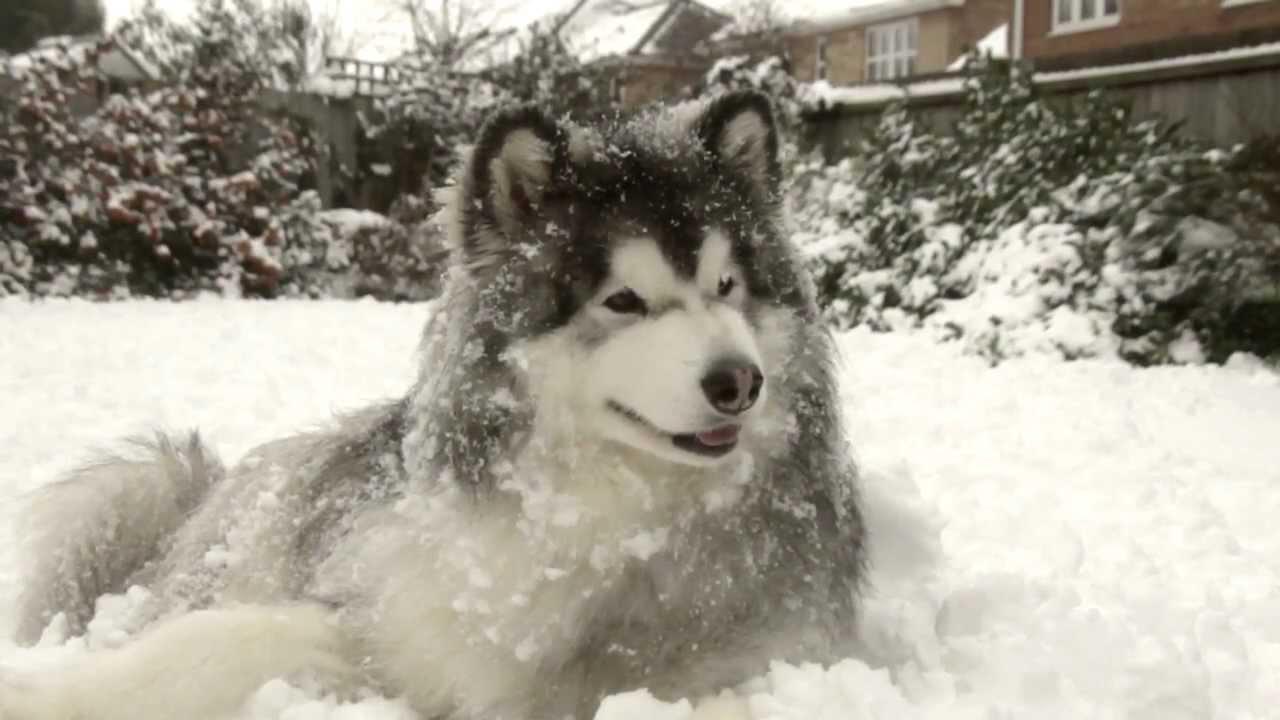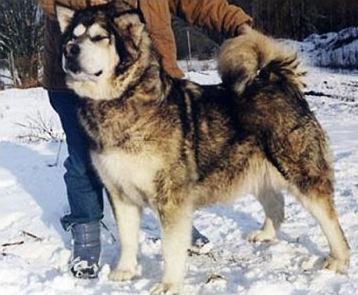The first image is the image on the left, the second image is the image on the right. Analyze the images presented: Is the assertion "The left and right image contains the same number of dogs with at least one standing in the snow." valid? Answer yes or no. Yes. The first image is the image on the left, the second image is the image on the right. Given the left and right images, does the statement "One image shows a dog sitting upright on snow-covered ground, and the other image shows a forward-facing dog with snow mounded in front of it." hold true? Answer yes or no. No. 